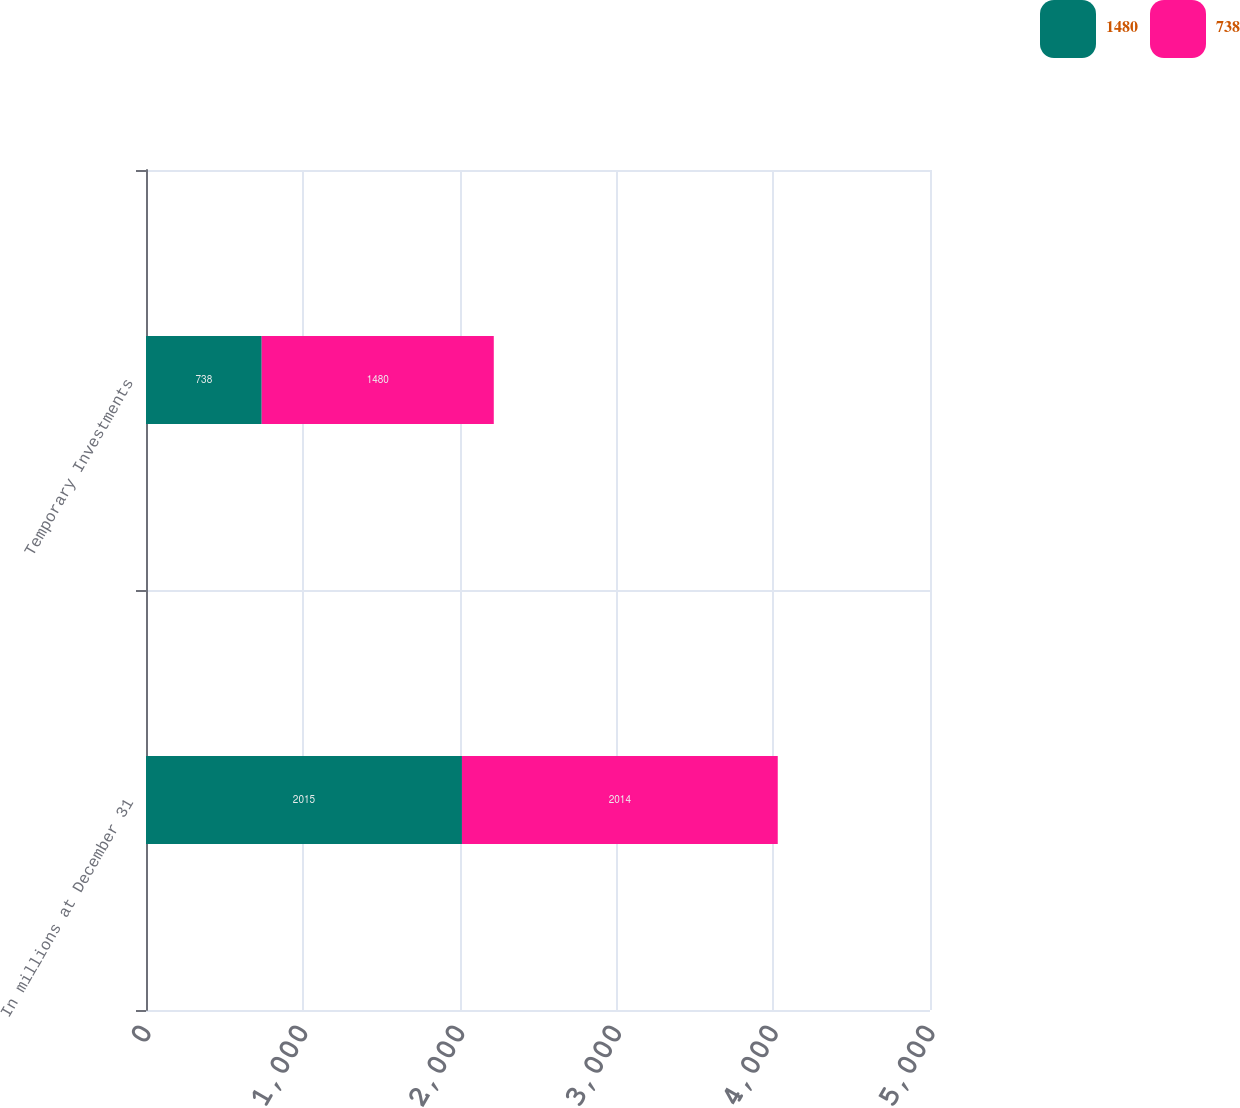Convert chart to OTSL. <chart><loc_0><loc_0><loc_500><loc_500><stacked_bar_chart><ecel><fcel>In millions at December 31<fcel>Temporary Investments<nl><fcel>1480<fcel>2015<fcel>738<nl><fcel>738<fcel>2014<fcel>1480<nl></chart> 